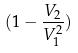Convert formula to latex. <formula><loc_0><loc_0><loc_500><loc_500>( 1 - \frac { V _ { 2 } } { V _ { 1 } ^ { 2 } } )</formula> 